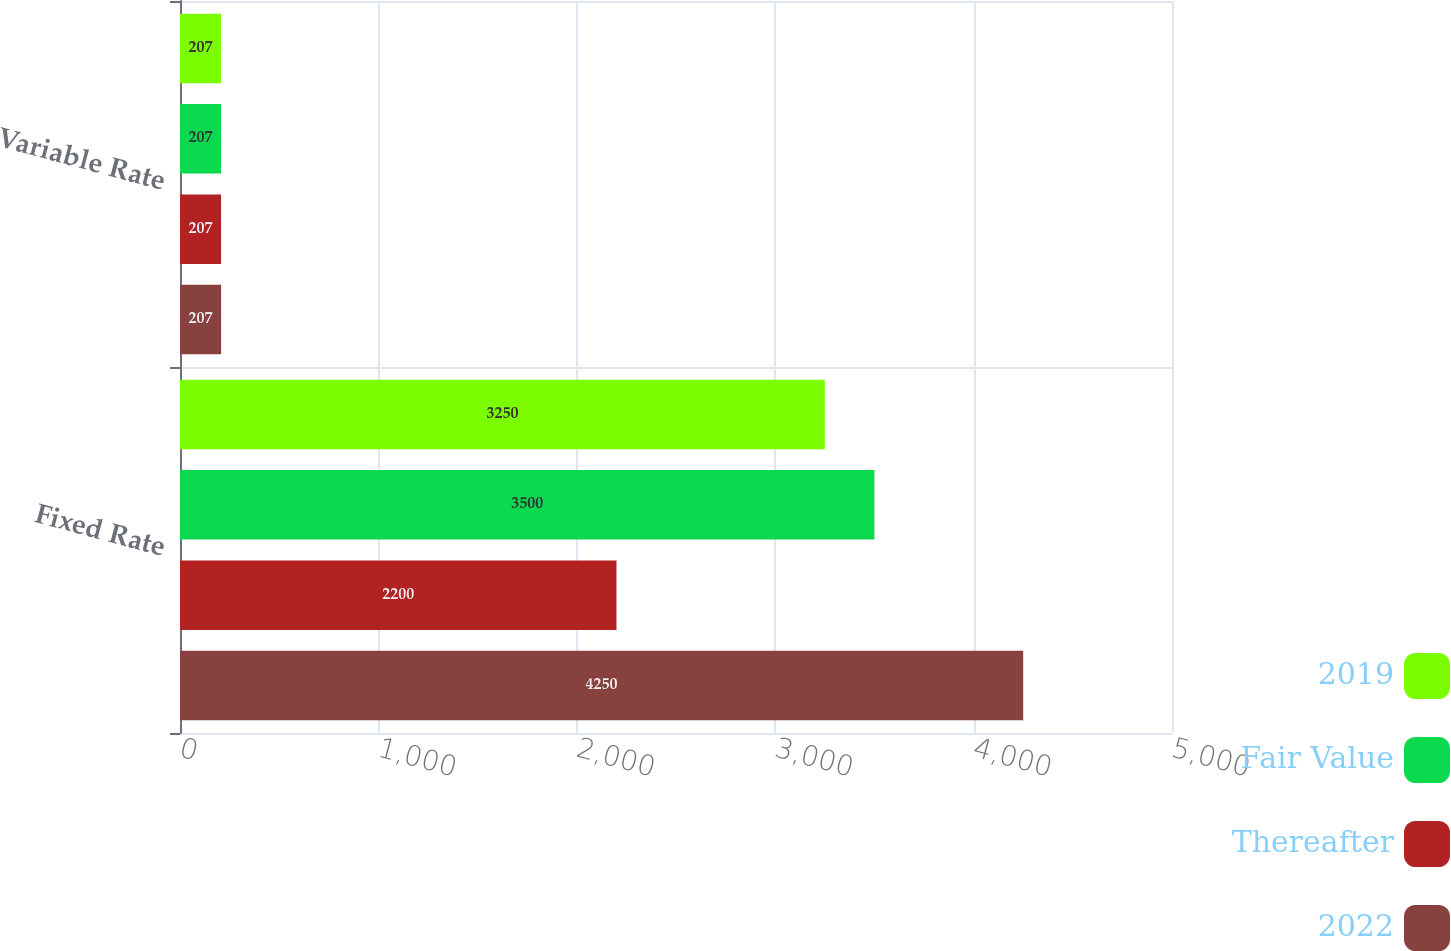Convert chart. <chart><loc_0><loc_0><loc_500><loc_500><stacked_bar_chart><ecel><fcel>Fixed Rate<fcel>Variable Rate<nl><fcel>2019<fcel>3250<fcel>207<nl><fcel>Fair Value<fcel>3500<fcel>207<nl><fcel>Thereafter<fcel>2200<fcel>207<nl><fcel>2022<fcel>4250<fcel>207<nl></chart> 